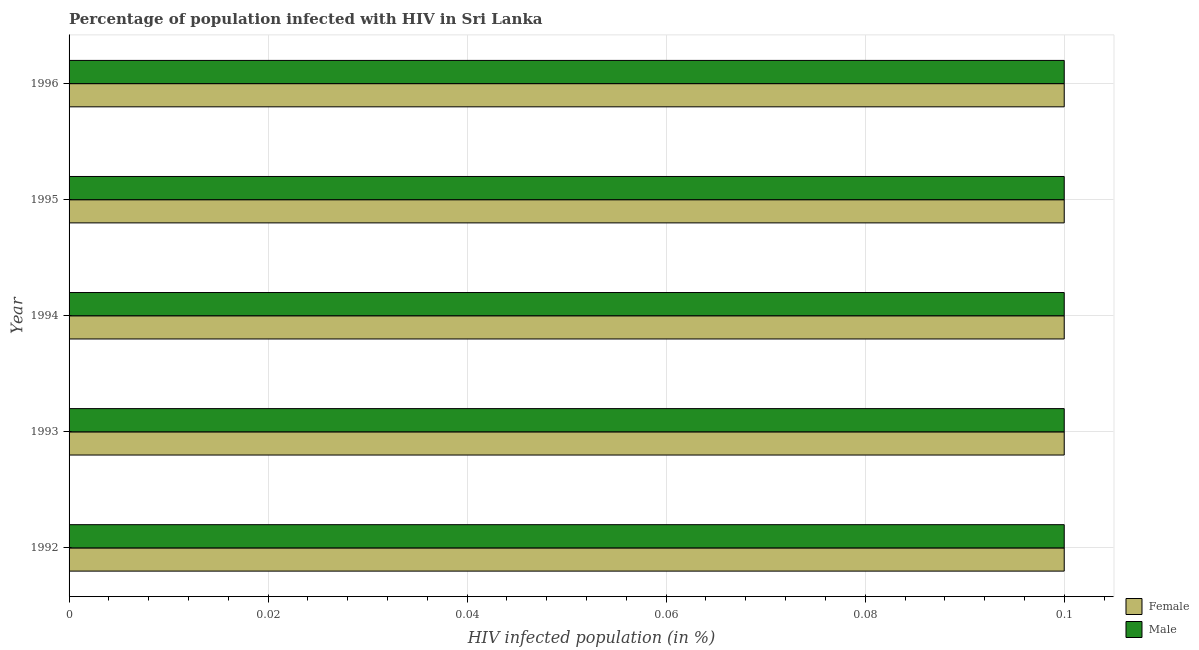How many different coloured bars are there?
Keep it short and to the point. 2. How many groups of bars are there?
Give a very brief answer. 5. How many bars are there on the 3rd tick from the top?
Offer a very short reply. 2. What is the percentage of males who are infected with hiv in 1993?
Your response must be concise. 0.1. Across all years, what is the minimum percentage of females who are infected with hiv?
Give a very brief answer. 0.1. In which year was the percentage of males who are infected with hiv maximum?
Ensure brevity in your answer.  1992. In which year was the percentage of females who are infected with hiv minimum?
Provide a short and direct response. 1992. What is the total percentage of females who are infected with hiv in the graph?
Provide a succinct answer. 0.5. What is the difference between the percentage of males who are infected with hiv in 1993 and that in 1994?
Provide a short and direct response. 0. What is the difference between the percentage of females who are infected with hiv in 1994 and the percentage of males who are infected with hiv in 1995?
Your response must be concise. 0. In the year 1995, what is the difference between the percentage of females who are infected with hiv and percentage of males who are infected with hiv?
Ensure brevity in your answer.  0. What is the ratio of the percentage of females who are infected with hiv in 1992 to that in 1994?
Your answer should be compact. 1. Is the percentage of females who are infected with hiv in 1992 less than that in 1994?
Provide a short and direct response. No. Is the difference between the percentage of females who are infected with hiv in 1993 and 1996 greater than the difference between the percentage of males who are infected with hiv in 1993 and 1996?
Give a very brief answer. No. What is the difference between the highest and the lowest percentage of females who are infected with hiv?
Offer a very short reply. 0. Is the sum of the percentage of males who are infected with hiv in 1993 and 1995 greater than the maximum percentage of females who are infected with hiv across all years?
Your answer should be compact. Yes. What does the 2nd bar from the bottom in 1993 represents?
Offer a terse response. Male. What is the difference between two consecutive major ticks on the X-axis?
Your answer should be compact. 0.02. How are the legend labels stacked?
Give a very brief answer. Vertical. What is the title of the graph?
Give a very brief answer. Percentage of population infected with HIV in Sri Lanka. Does "Female entrants" appear as one of the legend labels in the graph?
Offer a very short reply. No. What is the label or title of the X-axis?
Your answer should be compact. HIV infected population (in %). What is the HIV infected population (in %) in Female in 1993?
Ensure brevity in your answer.  0.1. What is the HIV infected population (in %) in Male in 1993?
Give a very brief answer. 0.1. What is the HIV infected population (in %) of Female in 1996?
Give a very brief answer. 0.1. Across all years, what is the maximum HIV infected population (in %) of Female?
Ensure brevity in your answer.  0.1. Across all years, what is the maximum HIV infected population (in %) of Male?
Provide a succinct answer. 0.1. Across all years, what is the minimum HIV infected population (in %) of Female?
Offer a terse response. 0.1. Across all years, what is the minimum HIV infected population (in %) of Male?
Offer a very short reply. 0.1. What is the total HIV infected population (in %) in Female in the graph?
Your answer should be compact. 0.5. What is the difference between the HIV infected population (in %) in Female in 1992 and that in 1993?
Ensure brevity in your answer.  0. What is the difference between the HIV infected population (in %) of Male in 1992 and that in 1993?
Offer a very short reply. 0. What is the difference between the HIV infected population (in %) in Female in 1992 and that in 1995?
Make the answer very short. 0. What is the difference between the HIV infected population (in %) in Female in 1993 and that in 1995?
Your answer should be compact. 0. What is the difference between the HIV infected population (in %) of Male in 1993 and that in 1995?
Keep it short and to the point. 0. What is the difference between the HIV infected population (in %) in Female in 1993 and that in 1996?
Keep it short and to the point. 0. What is the difference between the HIV infected population (in %) in Male in 1994 and that in 1995?
Keep it short and to the point. 0. What is the difference between the HIV infected population (in %) in Female in 1994 and that in 1996?
Your response must be concise. 0. What is the difference between the HIV infected population (in %) of Male in 1994 and that in 1996?
Ensure brevity in your answer.  0. What is the difference between the HIV infected population (in %) in Female in 1995 and that in 1996?
Offer a terse response. 0. What is the difference between the HIV infected population (in %) of Female in 1992 and the HIV infected population (in %) of Male in 1995?
Provide a succinct answer. 0. What is the difference between the HIV infected population (in %) of Female in 1992 and the HIV infected population (in %) of Male in 1996?
Offer a terse response. 0. What is the difference between the HIV infected population (in %) of Female in 1993 and the HIV infected population (in %) of Male in 1996?
Your response must be concise. 0. What is the difference between the HIV infected population (in %) of Female in 1994 and the HIV infected population (in %) of Male in 1995?
Provide a succinct answer. 0. What is the difference between the HIV infected population (in %) in Female in 1994 and the HIV infected population (in %) in Male in 1996?
Your answer should be very brief. 0. What is the average HIV infected population (in %) in Male per year?
Ensure brevity in your answer.  0.1. In the year 1994, what is the difference between the HIV infected population (in %) in Female and HIV infected population (in %) in Male?
Your answer should be very brief. 0. In the year 1995, what is the difference between the HIV infected population (in %) of Female and HIV infected population (in %) of Male?
Provide a short and direct response. 0. What is the ratio of the HIV infected population (in %) in Female in 1992 to that in 1993?
Provide a short and direct response. 1. What is the ratio of the HIV infected population (in %) of Male in 1992 to that in 1994?
Provide a succinct answer. 1. What is the ratio of the HIV infected population (in %) in Male in 1992 to that in 1996?
Give a very brief answer. 1. What is the ratio of the HIV infected population (in %) of Female in 1993 to that in 1995?
Your answer should be compact. 1. What is the ratio of the HIV infected population (in %) of Male in 1993 to that in 1996?
Your answer should be very brief. 1. What is the ratio of the HIV infected population (in %) of Female in 1994 to that in 1996?
Provide a succinct answer. 1. What is the ratio of the HIV infected population (in %) of Male in 1994 to that in 1996?
Give a very brief answer. 1. What is the ratio of the HIV infected population (in %) in Female in 1995 to that in 1996?
Provide a succinct answer. 1. What is the difference between the highest and the second highest HIV infected population (in %) in Female?
Provide a short and direct response. 0. What is the difference between the highest and the lowest HIV infected population (in %) of Female?
Give a very brief answer. 0. 